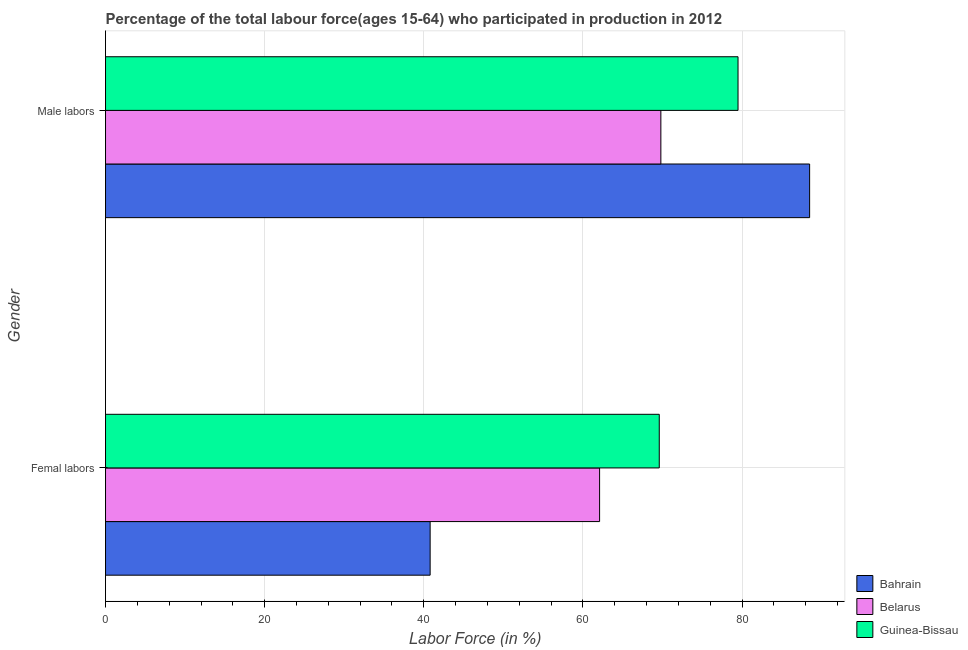How many different coloured bars are there?
Ensure brevity in your answer.  3. How many groups of bars are there?
Provide a short and direct response. 2. Are the number of bars on each tick of the Y-axis equal?
Keep it short and to the point. Yes. What is the label of the 1st group of bars from the top?
Keep it short and to the point. Male labors. What is the percentage of male labour force in Belarus?
Ensure brevity in your answer.  69.8. Across all countries, what is the maximum percentage of male labour force?
Provide a short and direct response. 88.5. Across all countries, what is the minimum percentage of female labor force?
Ensure brevity in your answer.  40.8. In which country was the percentage of male labour force maximum?
Give a very brief answer. Bahrain. In which country was the percentage of female labor force minimum?
Your answer should be compact. Bahrain. What is the total percentage of female labor force in the graph?
Offer a very short reply. 172.5. What is the difference between the percentage of male labour force in Belarus and the percentage of female labor force in Guinea-Bissau?
Your answer should be compact. 0.2. What is the average percentage of male labour force per country?
Provide a succinct answer. 79.27. What is the difference between the percentage of female labor force and percentage of male labour force in Bahrain?
Give a very brief answer. -47.7. What is the ratio of the percentage of female labor force in Bahrain to that in Guinea-Bissau?
Your answer should be very brief. 0.59. What does the 3rd bar from the top in Male labors represents?
Offer a terse response. Bahrain. What does the 1st bar from the bottom in Male labors represents?
Give a very brief answer. Bahrain. How many bars are there?
Ensure brevity in your answer.  6. How many countries are there in the graph?
Provide a short and direct response. 3. What is the difference between two consecutive major ticks on the X-axis?
Keep it short and to the point. 20. Are the values on the major ticks of X-axis written in scientific E-notation?
Your answer should be very brief. No. How many legend labels are there?
Your response must be concise. 3. How are the legend labels stacked?
Your answer should be very brief. Vertical. What is the title of the graph?
Provide a succinct answer. Percentage of the total labour force(ages 15-64) who participated in production in 2012. What is the label or title of the X-axis?
Provide a short and direct response. Labor Force (in %). What is the Labor Force (in %) in Bahrain in Femal labors?
Offer a very short reply. 40.8. What is the Labor Force (in %) of Belarus in Femal labors?
Provide a succinct answer. 62.1. What is the Labor Force (in %) in Guinea-Bissau in Femal labors?
Keep it short and to the point. 69.6. What is the Labor Force (in %) of Bahrain in Male labors?
Give a very brief answer. 88.5. What is the Labor Force (in %) of Belarus in Male labors?
Your response must be concise. 69.8. What is the Labor Force (in %) in Guinea-Bissau in Male labors?
Your answer should be compact. 79.5. Across all Gender, what is the maximum Labor Force (in %) of Bahrain?
Ensure brevity in your answer.  88.5. Across all Gender, what is the maximum Labor Force (in %) in Belarus?
Ensure brevity in your answer.  69.8. Across all Gender, what is the maximum Labor Force (in %) in Guinea-Bissau?
Provide a short and direct response. 79.5. Across all Gender, what is the minimum Labor Force (in %) in Bahrain?
Provide a short and direct response. 40.8. Across all Gender, what is the minimum Labor Force (in %) of Belarus?
Your answer should be compact. 62.1. Across all Gender, what is the minimum Labor Force (in %) of Guinea-Bissau?
Offer a very short reply. 69.6. What is the total Labor Force (in %) in Bahrain in the graph?
Keep it short and to the point. 129.3. What is the total Labor Force (in %) of Belarus in the graph?
Keep it short and to the point. 131.9. What is the total Labor Force (in %) of Guinea-Bissau in the graph?
Give a very brief answer. 149.1. What is the difference between the Labor Force (in %) of Bahrain in Femal labors and that in Male labors?
Keep it short and to the point. -47.7. What is the difference between the Labor Force (in %) in Guinea-Bissau in Femal labors and that in Male labors?
Keep it short and to the point. -9.9. What is the difference between the Labor Force (in %) in Bahrain in Femal labors and the Labor Force (in %) in Belarus in Male labors?
Offer a very short reply. -29. What is the difference between the Labor Force (in %) of Bahrain in Femal labors and the Labor Force (in %) of Guinea-Bissau in Male labors?
Offer a terse response. -38.7. What is the difference between the Labor Force (in %) of Belarus in Femal labors and the Labor Force (in %) of Guinea-Bissau in Male labors?
Provide a short and direct response. -17.4. What is the average Labor Force (in %) of Bahrain per Gender?
Offer a terse response. 64.65. What is the average Labor Force (in %) of Belarus per Gender?
Offer a very short reply. 65.95. What is the average Labor Force (in %) in Guinea-Bissau per Gender?
Make the answer very short. 74.55. What is the difference between the Labor Force (in %) of Bahrain and Labor Force (in %) of Belarus in Femal labors?
Your answer should be very brief. -21.3. What is the difference between the Labor Force (in %) of Bahrain and Labor Force (in %) of Guinea-Bissau in Femal labors?
Keep it short and to the point. -28.8. What is the difference between the Labor Force (in %) in Belarus and Labor Force (in %) in Guinea-Bissau in Femal labors?
Offer a terse response. -7.5. What is the difference between the Labor Force (in %) of Bahrain and Labor Force (in %) of Belarus in Male labors?
Give a very brief answer. 18.7. What is the difference between the Labor Force (in %) in Belarus and Labor Force (in %) in Guinea-Bissau in Male labors?
Give a very brief answer. -9.7. What is the ratio of the Labor Force (in %) in Bahrain in Femal labors to that in Male labors?
Offer a terse response. 0.46. What is the ratio of the Labor Force (in %) of Belarus in Femal labors to that in Male labors?
Ensure brevity in your answer.  0.89. What is the ratio of the Labor Force (in %) of Guinea-Bissau in Femal labors to that in Male labors?
Offer a terse response. 0.88. What is the difference between the highest and the second highest Labor Force (in %) in Bahrain?
Your response must be concise. 47.7. What is the difference between the highest and the lowest Labor Force (in %) of Bahrain?
Make the answer very short. 47.7. What is the difference between the highest and the lowest Labor Force (in %) in Belarus?
Offer a very short reply. 7.7. 